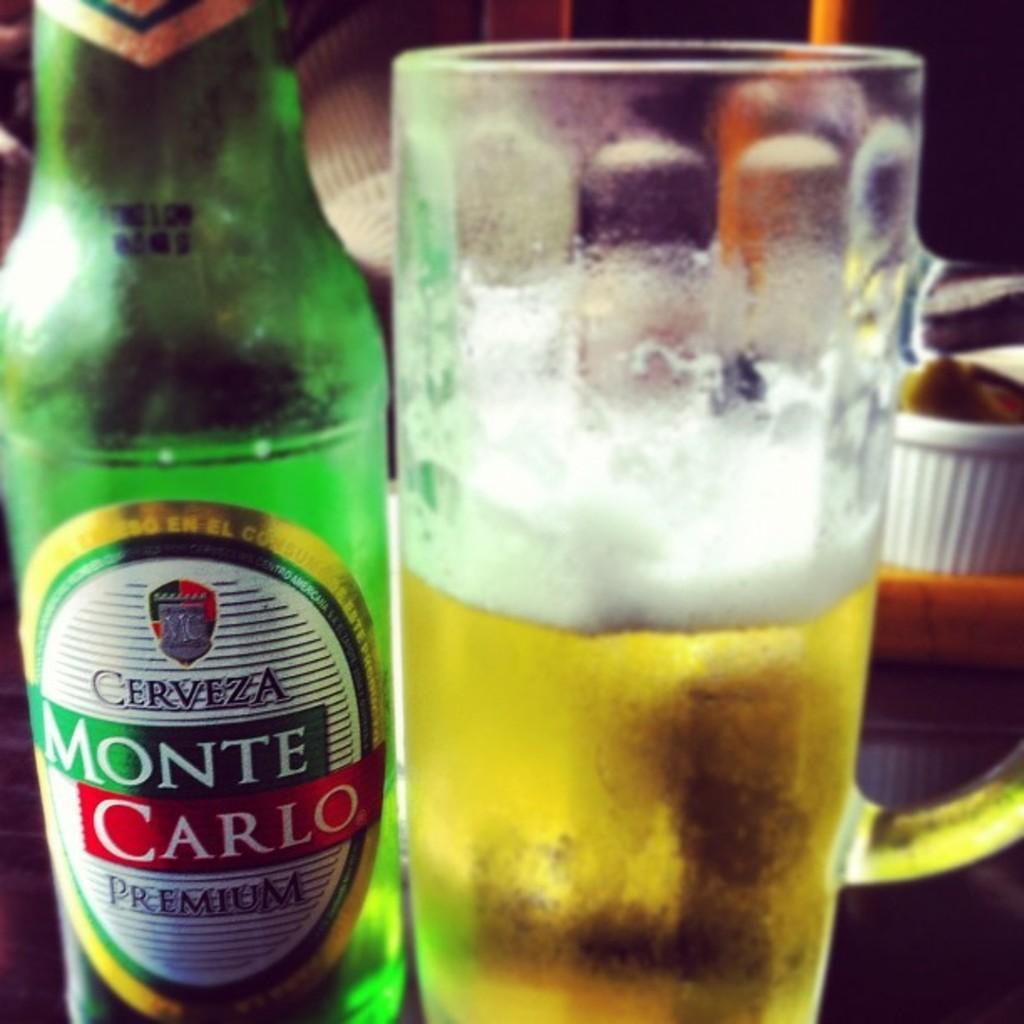Could you give a brief overview of what you see in this image? here is a glass of drink and on the left side there is a bottle on which monte carlo is written. 